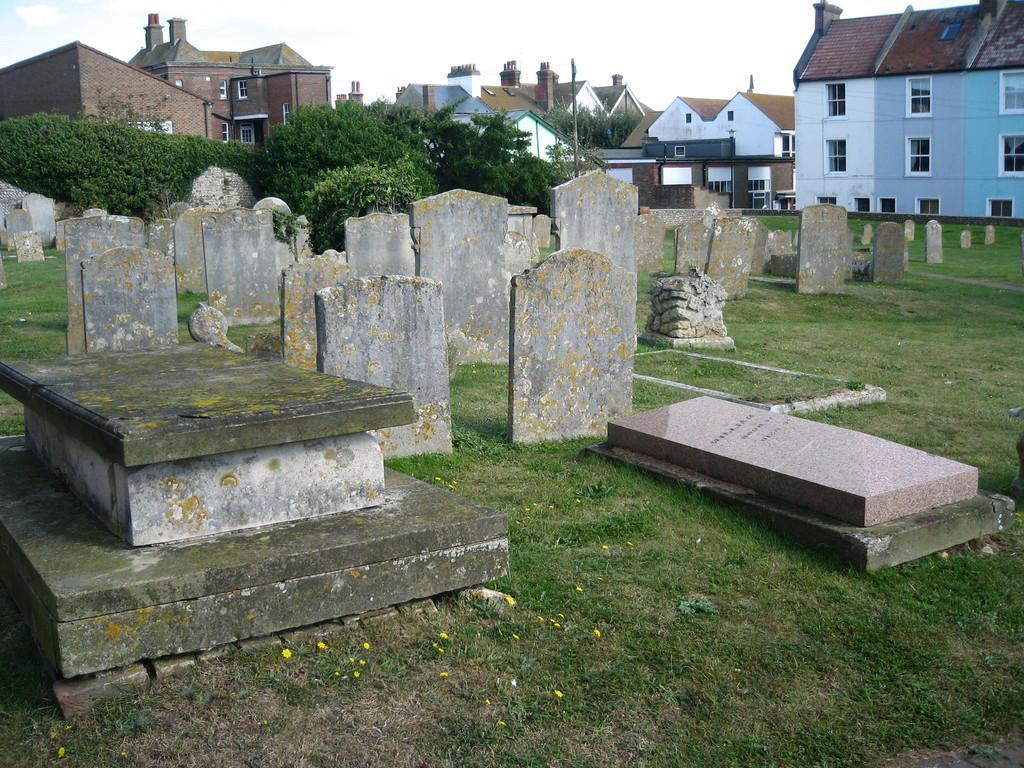Could you give a brief overview of what you see in this image? In this image there is the sky truncated towards the top of the image, there are buildings, there is a building truncated towards the right of the image, there is a building truncated towards the left of the image, there are trees, there is a tree truncated towards the left of the image, there is a graveyard, there is grass truncated towards the bottom of the image, there is grass truncated towards the right of the image, there are objects on the grass, there is a pole, there are windows. 